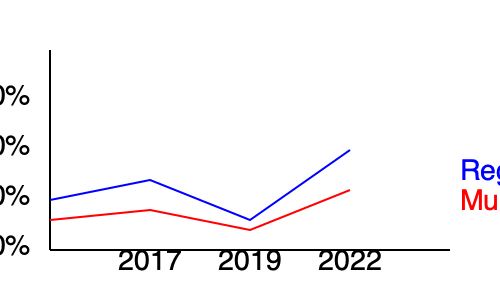Based on the line graph showing voter turnout in Allier's recent elections, what was the difference in percentage points between the regional and municipal election turnouts in 2022? To find the difference in percentage points between the regional and municipal election turnouts in 2022, we need to:

1. Identify the 2022 data points (the rightmost points on each line):
   - Regional election (blue line): approximately 70%
   - Municipal election (red line): approximately 62%

2. Calculate the difference:
   $70\% - 62\% = 8\%$

Therefore, the difference in percentage points between the regional and municipal election turnouts in 2022 was approximately 8 percentage points.

Note: The exact percentages may vary slightly due to the visual estimation from the graph, but the difference should be close to 8 percentage points.
Answer: 8 percentage points 